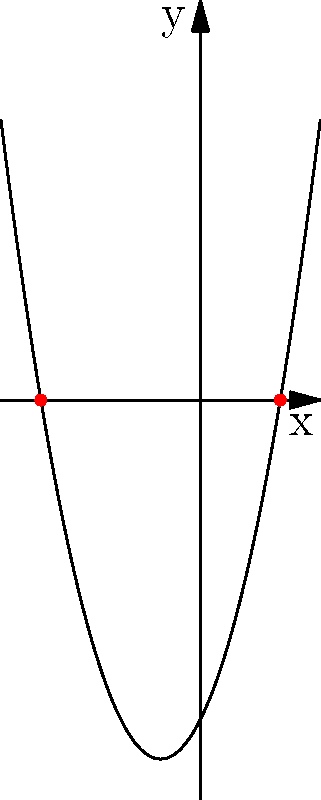The graph of a quadratic function $f(x) = x^2 + 2x - 8$ is shown above. Determine the roots of the equation $f(x) = 0$ by finding the x-intercepts of the parabola. To solve this problem, we need to follow these steps:

1) The x-intercepts of a parabola are the points where the parabola crosses the x-axis. At these points, the y-coordinate is zero.

2) From the graph, we can see that the parabola crosses the x-axis at two points.

3) The x-coordinates of these points are the roots of the equation $f(x) = 0$.

4) By observing the graph carefully, we can see that these points are at $x = -4$ and $x = 2$.

5) We can verify this by substituting these values into the original equation:

   For $x = -4$: $f(-4) = (-4)^2 + 2(-4) - 8 = 16 - 8 - 8 = 0$
   For $x = 2$: $f(2) = (2)^2 + 2(2) - 8 = 4 + 4 - 8 = 0$

6) Therefore, the roots of the equation $f(x) = 0$ are $x = -4$ and $x = 2$.
Answer: $x = -4$ and $x = 2$ 